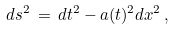<formula> <loc_0><loc_0><loc_500><loc_500>d s ^ { 2 } \, = \, d t ^ { 2 } - a ( t ) ^ { 2 } d { x } ^ { 2 } \, ,</formula> 